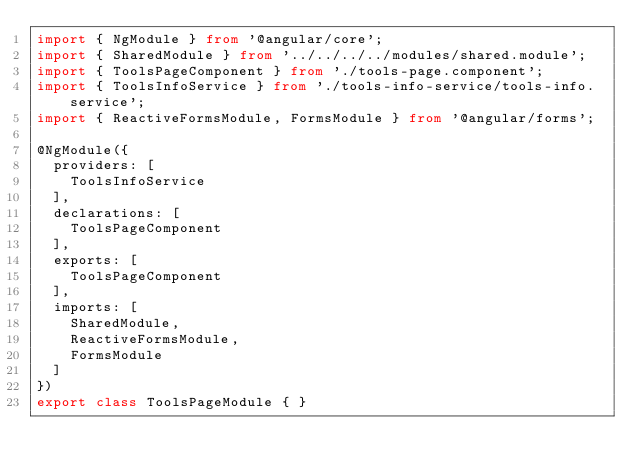Convert code to text. <code><loc_0><loc_0><loc_500><loc_500><_TypeScript_>import { NgModule } from '@angular/core';
import { SharedModule } from '../../../../modules/shared.module';
import { ToolsPageComponent } from './tools-page.component';
import { ToolsInfoService } from './tools-info-service/tools-info.service';
import { ReactiveFormsModule, FormsModule } from '@angular/forms';

@NgModule({
  providers: [
    ToolsInfoService
  ],
  declarations: [
    ToolsPageComponent
  ],
  exports: [
    ToolsPageComponent
  ],
  imports: [
    SharedModule,
    ReactiveFormsModule,
    FormsModule
  ]
})
export class ToolsPageModule { }
</code> 